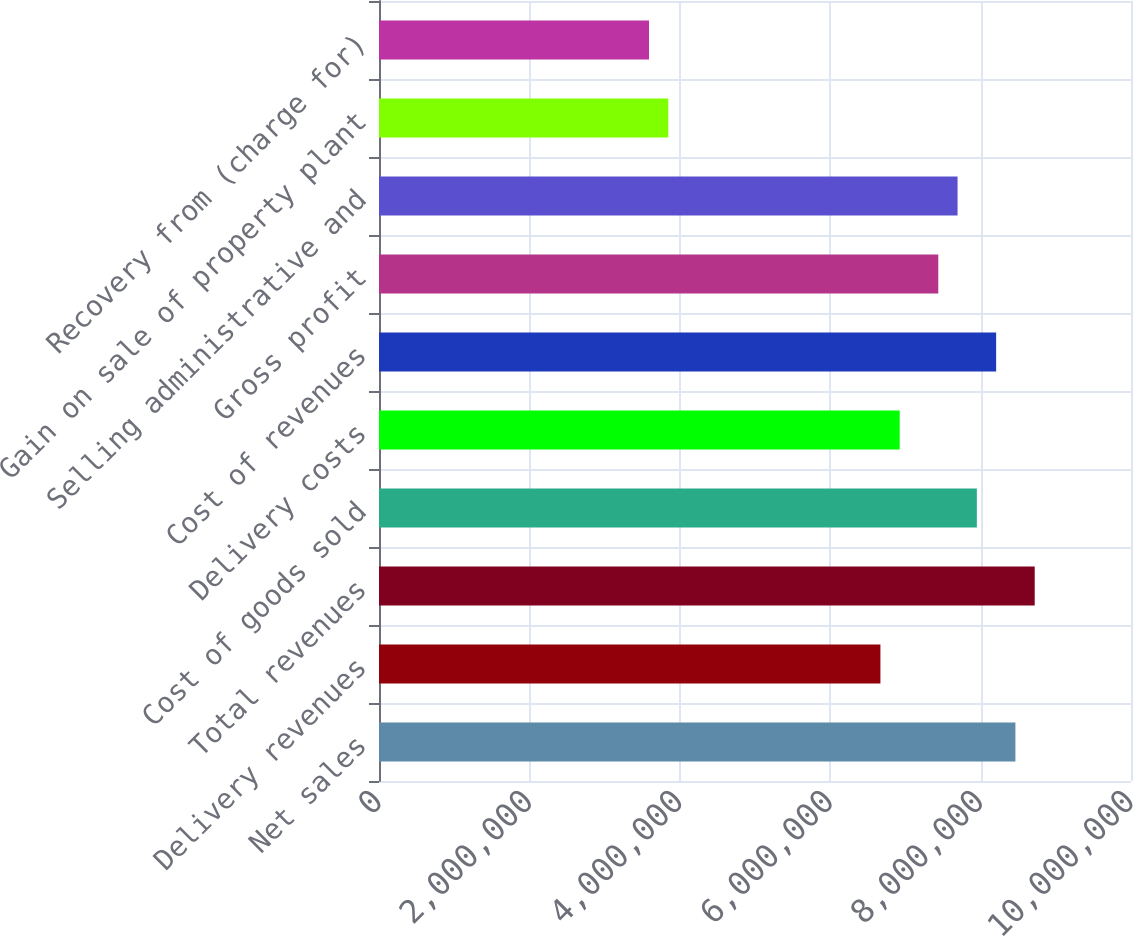<chart> <loc_0><loc_0><loc_500><loc_500><bar_chart><fcel>Net sales<fcel>Delivery revenues<fcel>Total revenues<fcel>Cost of goods sold<fcel>Delivery costs<fcel>Cost of revenues<fcel>Gross profit<fcel>Selling administrative and<fcel>Gain on sale of property plant<fcel>Recovery from (charge for)<nl><fcel>8.46302e+06<fcel>6.66783e+06<fcel>8.71947e+06<fcel>7.95011e+06<fcel>6.92429e+06<fcel>8.20656e+06<fcel>7.4372e+06<fcel>7.69365e+06<fcel>3.84683e+06<fcel>3.59037e+06<nl></chart> 